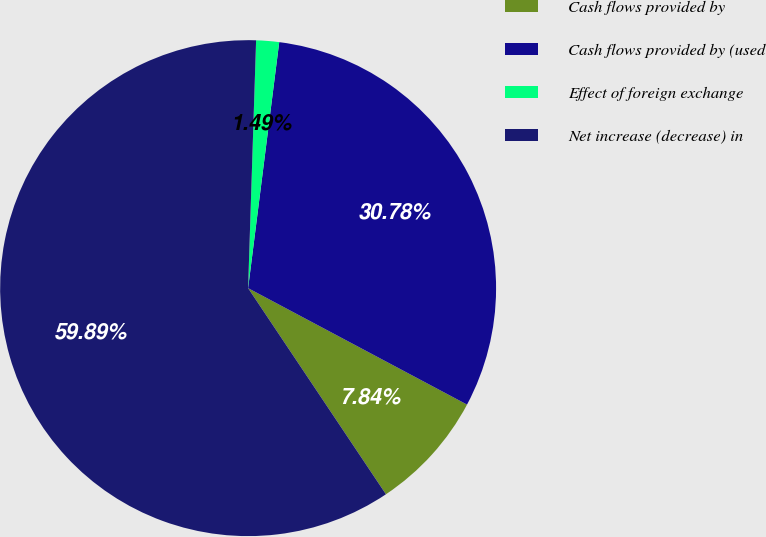Convert chart. <chart><loc_0><loc_0><loc_500><loc_500><pie_chart><fcel>Cash flows provided by<fcel>Cash flows provided by (used<fcel>Effect of foreign exchange<fcel>Net increase (decrease) in<nl><fcel>7.84%<fcel>30.78%<fcel>1.49%<fcel>59.9%<nl></chart> 